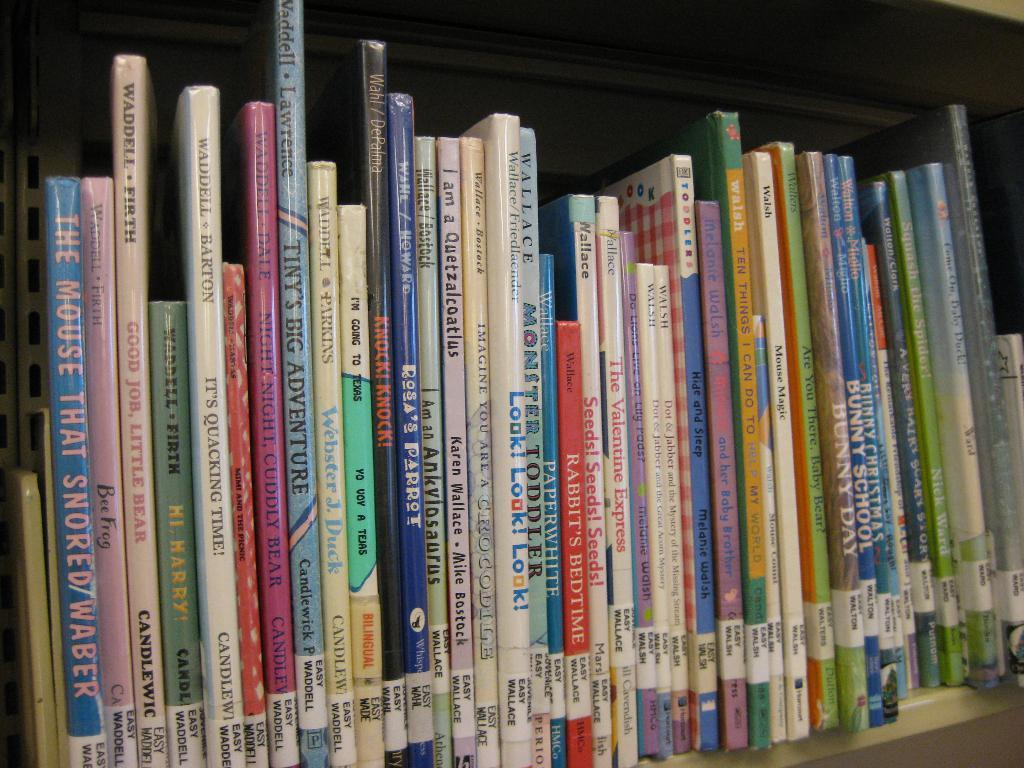<image>
Share a concise interpretation of the image provided. The book on the far left of the bookshelf is The Mouse That Snored. 